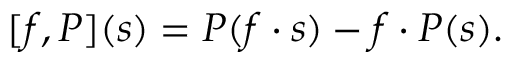Convert formula to latex. <formula><loc_0><loc_0><loc_500><loc_500>[ f , P ] ( s ) = P ( f \cdot s ) - f \cdot P ( s ) .</formula> 